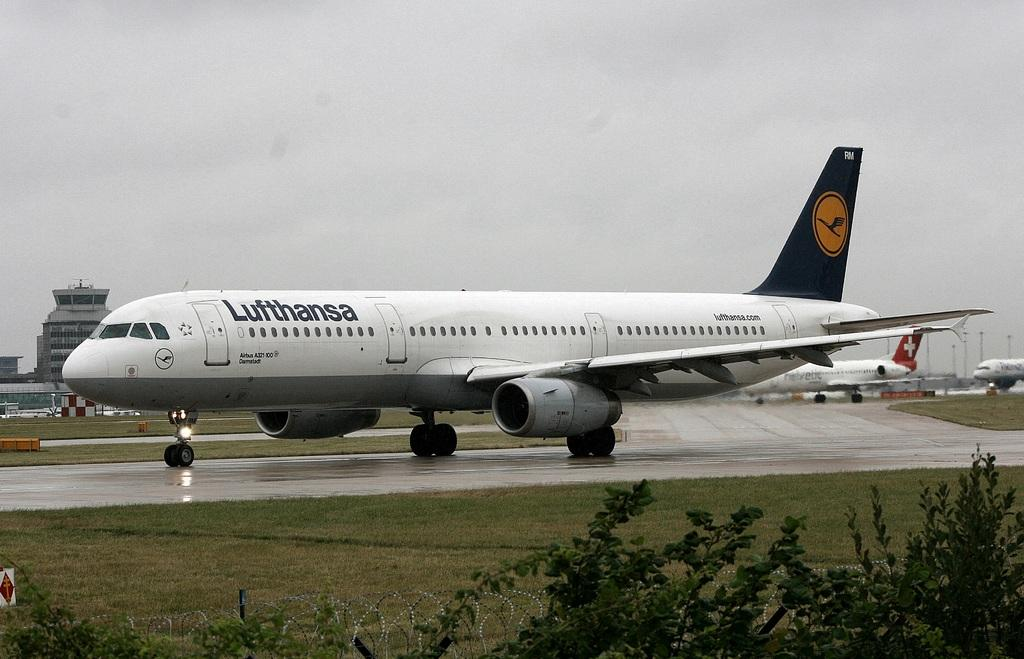<image>
Offer a succinct explanation of the picture presented. A Lufthansa aircraft sits on a wet runway. 